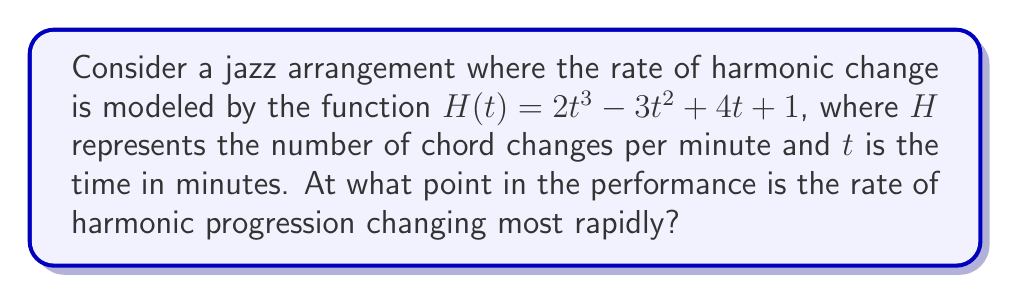Give your solution to this math problem. To find the point where the rate of harmonic progression is changing most rapidly, we need to follow these steps:

1) First, we need to find the derivative of $H(t)$ with respect to $t$. This gives us the rate of change of the harmonic progression:

   $$H'(t) = 6t^2 - 6t + 4$$

2) The second derivative of $H(t)$ will give us the rate of change of the rate of change, or in other words, how rapidly the rate is changing:

   $$H''(t) = 12t - 6$$

3) The point where the rate is changing most rapidly will be where $H''(t)$ is at its maximum or minimum. To find this, we set $H''(t) = 0$ and solve for $t$:

   $$12t - 6 = 0$$
   $$12t = 6$$
   $$t = \frac{1}{2}$$

4) To confirm this is a maximum (rather than a minimum), we can check the sign of $H''(t)$ on either side of $t = \frac{1}{2}$:

   When $t < \frac{1}{2}$, $H''(t) < 0$
   When $t > \frac{1}{2}$, $H''(t) > 0$

   This confirms that $t = \frac{1}{2}$ is indeed a minimum of $H''(t)$, which corresponds to the point of most rapid change in $H'(t)$.

5) Therefore, the rate of harmonic progression is changing most rapidly at $t = \frac{1}{2}$ minutes into the performance.
Answer: $\frac{1}{2}$ minutes 